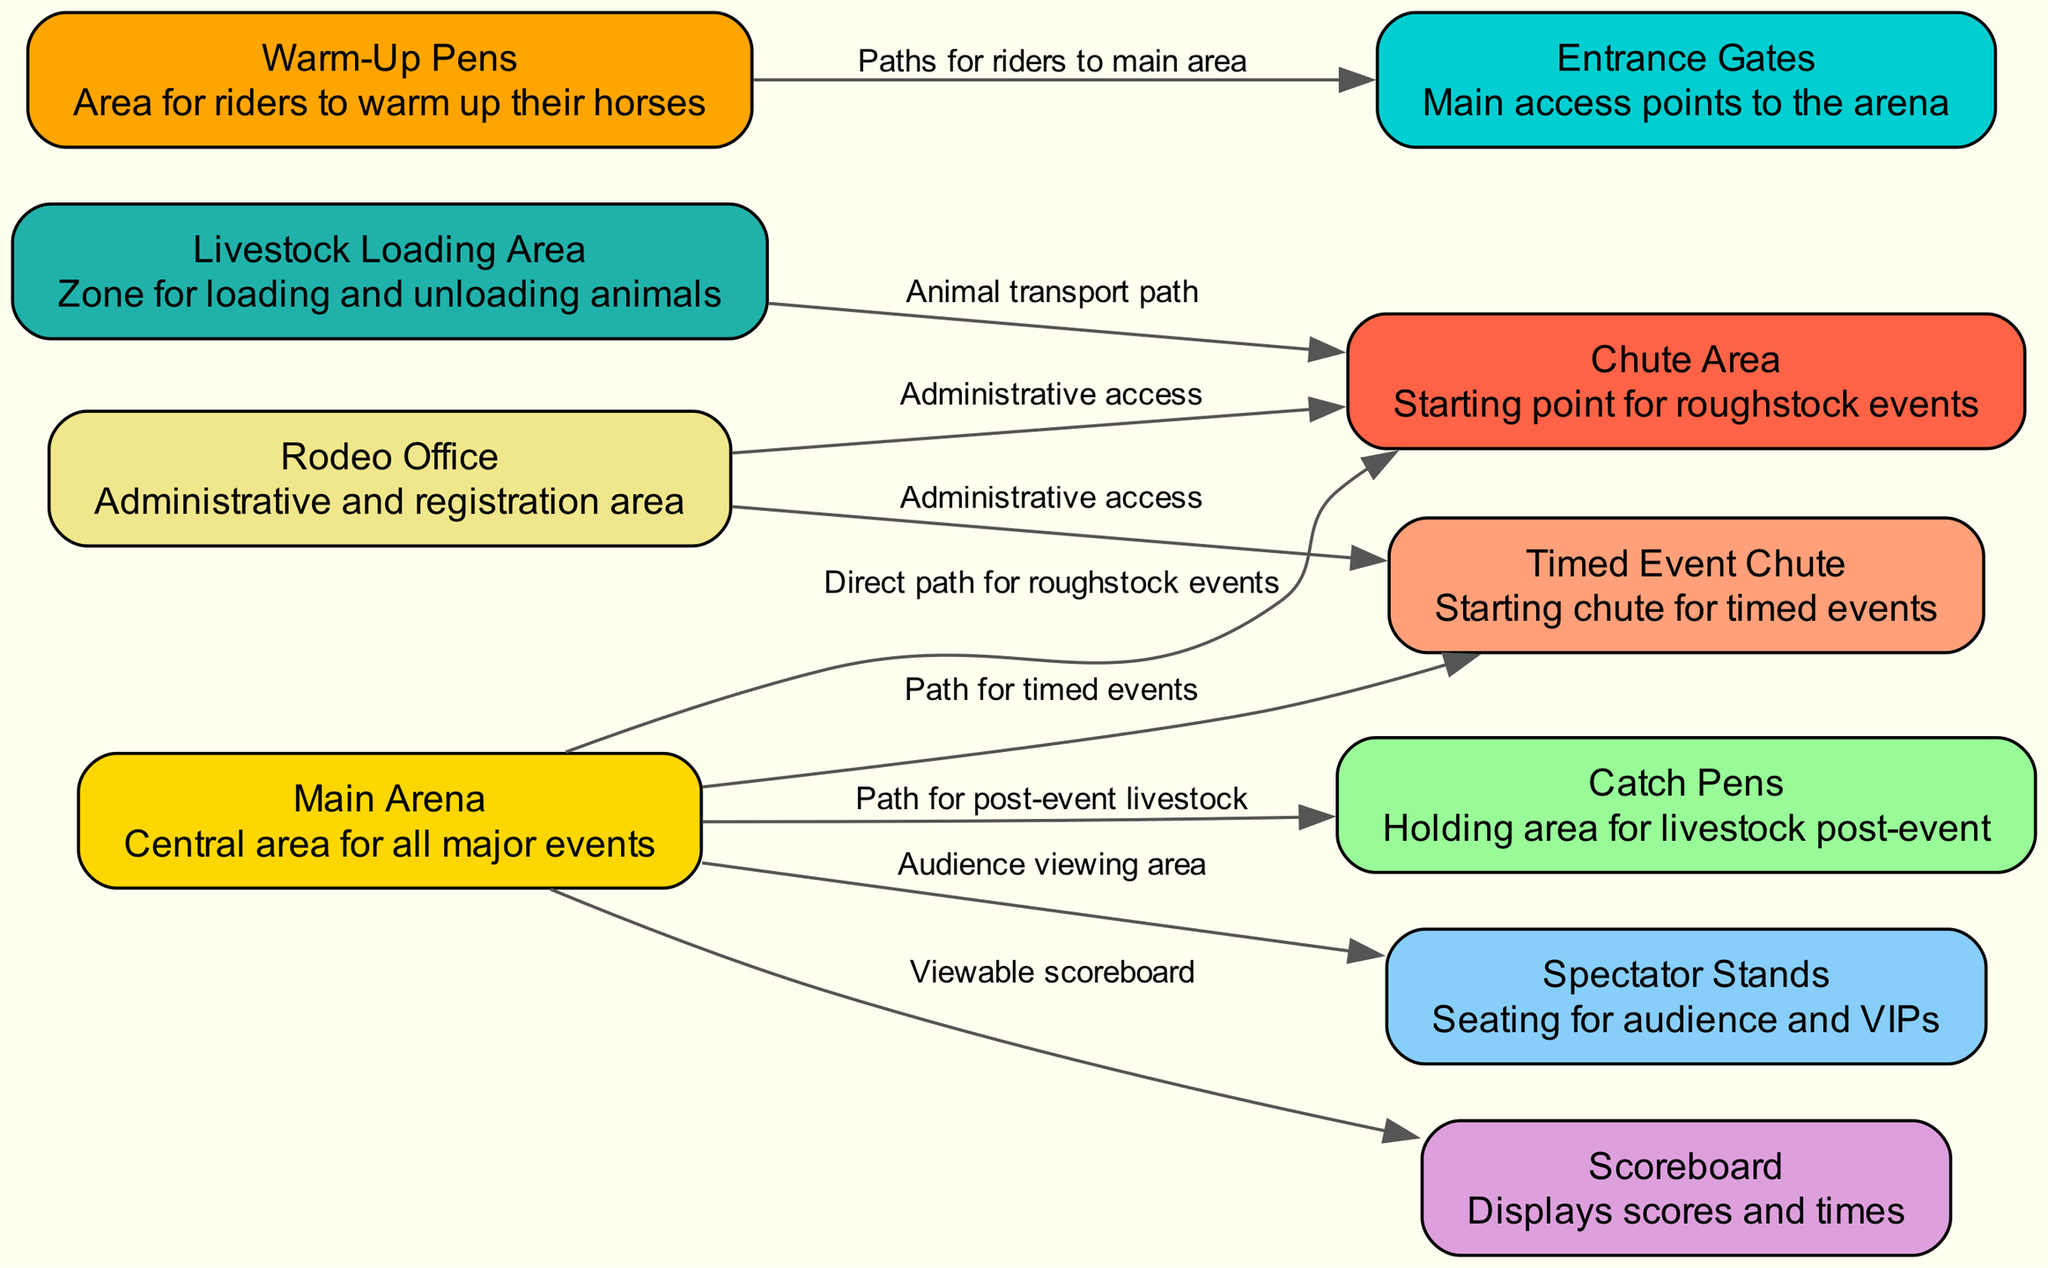What is the central area for all major events? Referring to the diagram, the node labeled "Main Arena" signifies the central area where all major rodeo events take place, as described.
Answer: Main Arena How many key areas are shown in the diagram? By counting the nodes in the diagram, there are a total of 10 key areas that describe different parts of the rodeo arena.
Answer: 10 Which area is the starting point for roughstock events? According to the node descriptions, the "Chute Area" is specifically designated as the starting point for roughstock events.
Answer: Chute Area What is the path from the main arena to the spectator stands? The edge from "Main Arena" to "Spectator Stands" indicates a direct path for audience viewing, making this the defined connection.
Answer: Path for audience viewing Which area allows for administrative access to both the chute area and timed event chute? The "Rodeo Office" node provides administrative access to both the "Chute Area" and "Timed Event Chute" as indicated in the edges that connect these nodes.
Answer: Rodeo Office What area is intended for loading and unloading animals? The "Livestock Loading Area" is specified in the diagram as the designated zone for loading and unloading livestock, as described in its node details.
Answer: Livestock Loading Area If a rider is in the warm-up pens, what is their path to the main area? The edge connecting "Warm-Up Pens" to "Entrance Gates" indicates that riders can access the main area from the warm-up pens via this path.
Answer: Paths for riders to main area What does the scoreboard display? The "Scoreboard" node is described as displaying scores and times, highlighting its function within the rodeo event setup.
Answer: Displays scores and times What area holds livestock post-event? The "Catch Pens" are noted as the holding area for livestock after events, according to the diagram's node descriptions.
Answer: Catch Pens How is livestock transported to the chute area? The edge from "Livestock Loading Area" to "Chute Area" indicates this is the path for transporting animals, establishing the flow of operations.
Answer: Animal transport path 